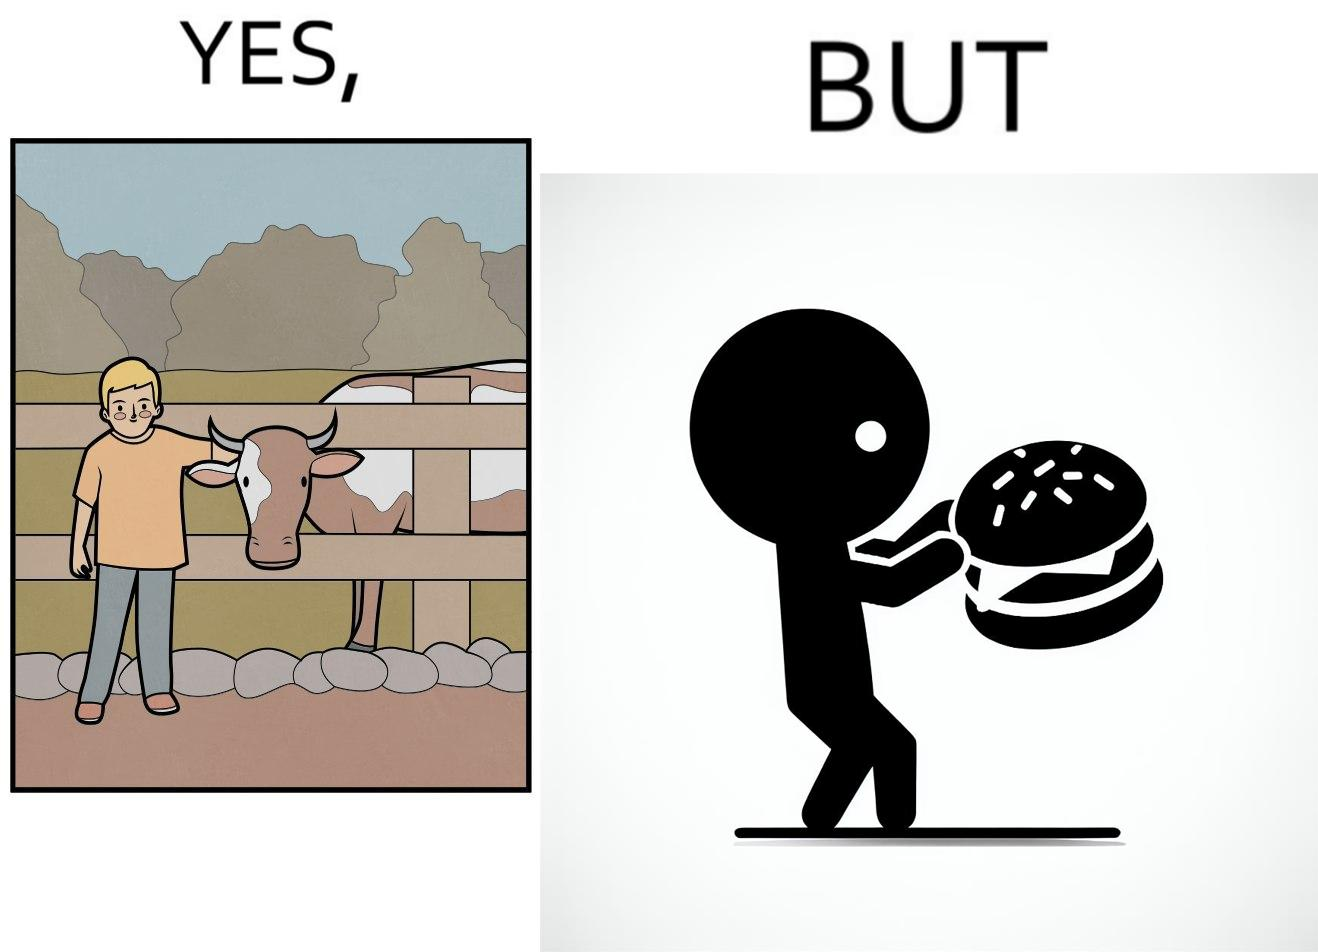Describe the satirical element in this image. The irony is that the boy is petting the cow to show that he cares about the animal, but then he also eats hamburgers made from the same cows 